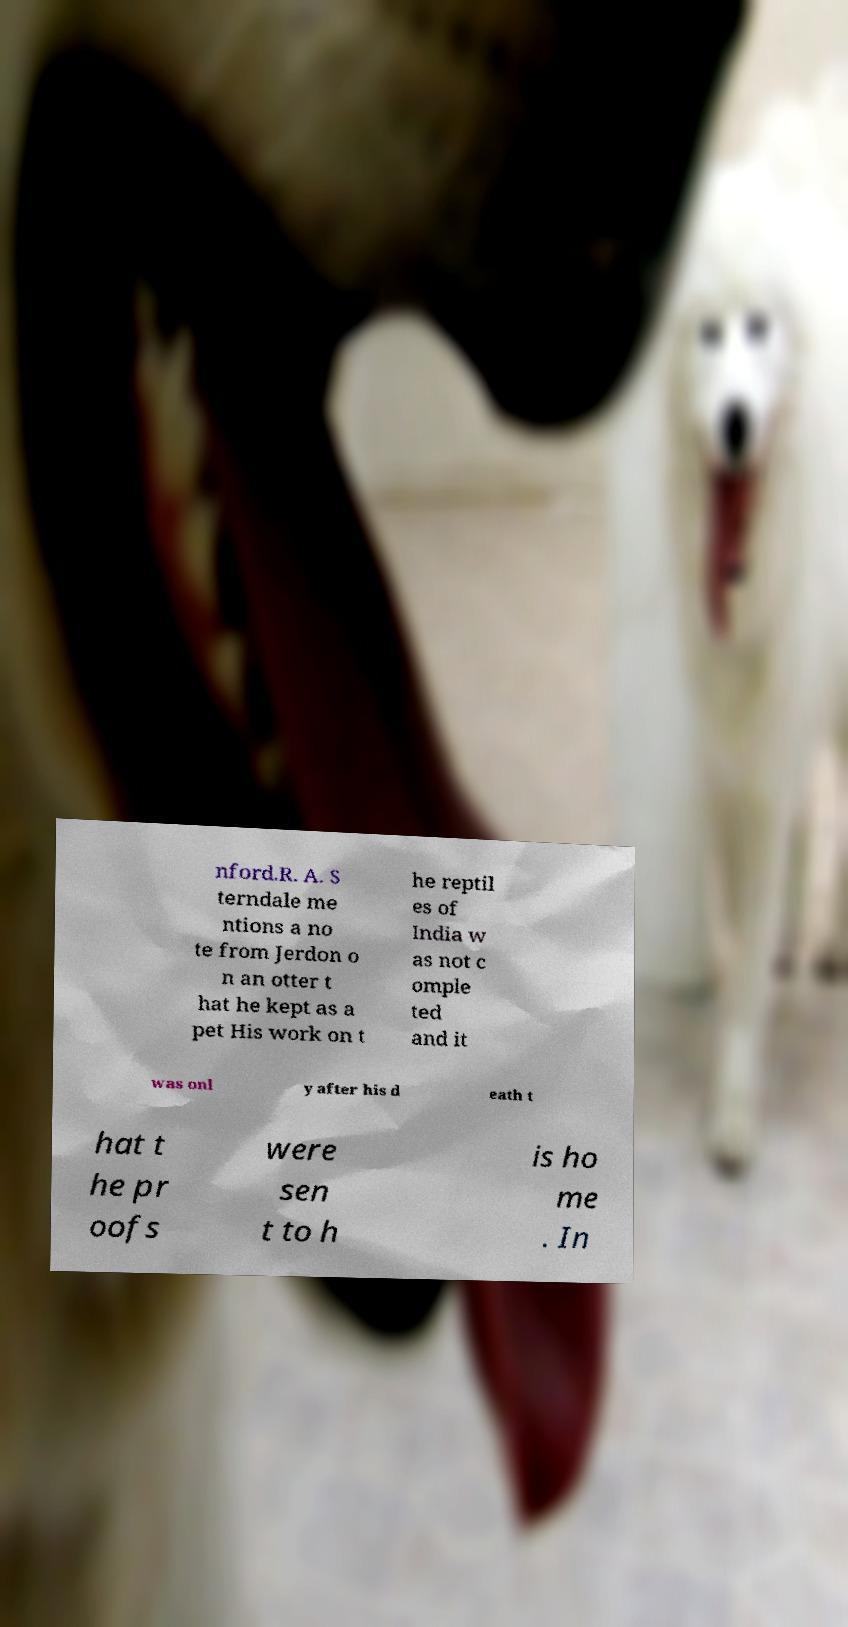Please read and relay the text visible in this image. What does it say? nford.R. A. S terndale me ntions a no te from Jerdon o n an otter t hat he kept as a pet His work on t he reptil es of India w as not c omple ted and it was onl y after his d eath t hat t he pr oofs were sen t to h is ho me . In 